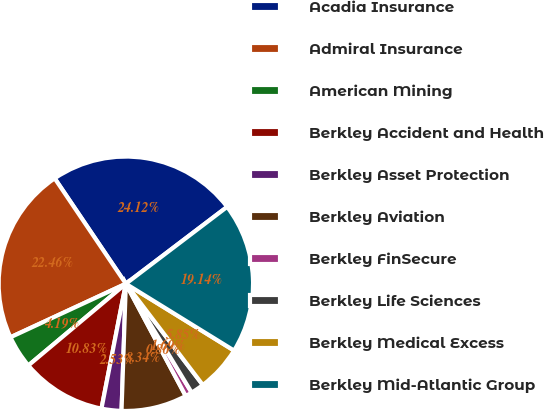Convert chart to OTSL. <chart><loc_0><loc_0><loc_500><loc_500><pie_chart><fcel>Acadia Insurance<fcel>Admiral Insurance<fcel>American Mining<fcel>Berkley Accident and Health<fcel>Berkley Asset Protection<fcel>Berkley Aviation<fcel>Berkley FinSecure<fcel>Berkley Life Sciences<fcel>Berkley Medical Excess<fcel>Berkley Mid-Atlantic Group<nl><fcel>24.12%<fcel>22.46%<fcel>4.19%<fcel>10.83%<fcel>2.53%<fcel>8.34%<fcel>0.86%<fcel>1.69%<fcel>5.85%<fcel>19.14%<nl></chart> 